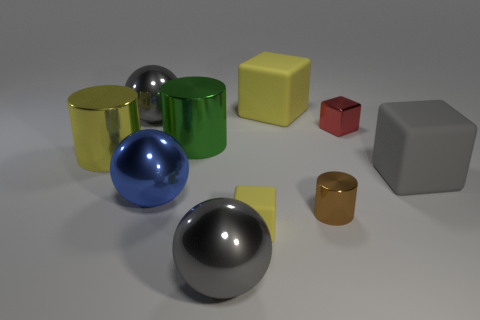Subtract all gray matte blocks. How many blocks are left? 3 Subtract all cylinders. How many objects are left? 7 Subtract 1 cylinders. How many cylinders are left? 2 Subtract all gray cubes. How many cubes are left? 3 Subtract all blue balls. Subtract all purple blocks. How many balls are left? 2 Subtract all purple blocks. How many brown cylinders are left? 1 Subtract all cubes. Subtract all large green things. How many objects are left? 5 Add 2 small yellow things. How many small yellow things are left? 3 Add 2 brown matte cylinders. How many brown matte cylinders exist? 2 Subtract 0 red cylinders. How many objects are left? 10 